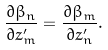<formula> <loc_0><loc_0><loc_500><loc_500>\frac { \partial \beta _ { n } } { \partial z ^ { \prime } _ { m } } = \frac { \partial \beta _ { m } } { \partial z ^ { \prime } _ { n } } .</formula> 